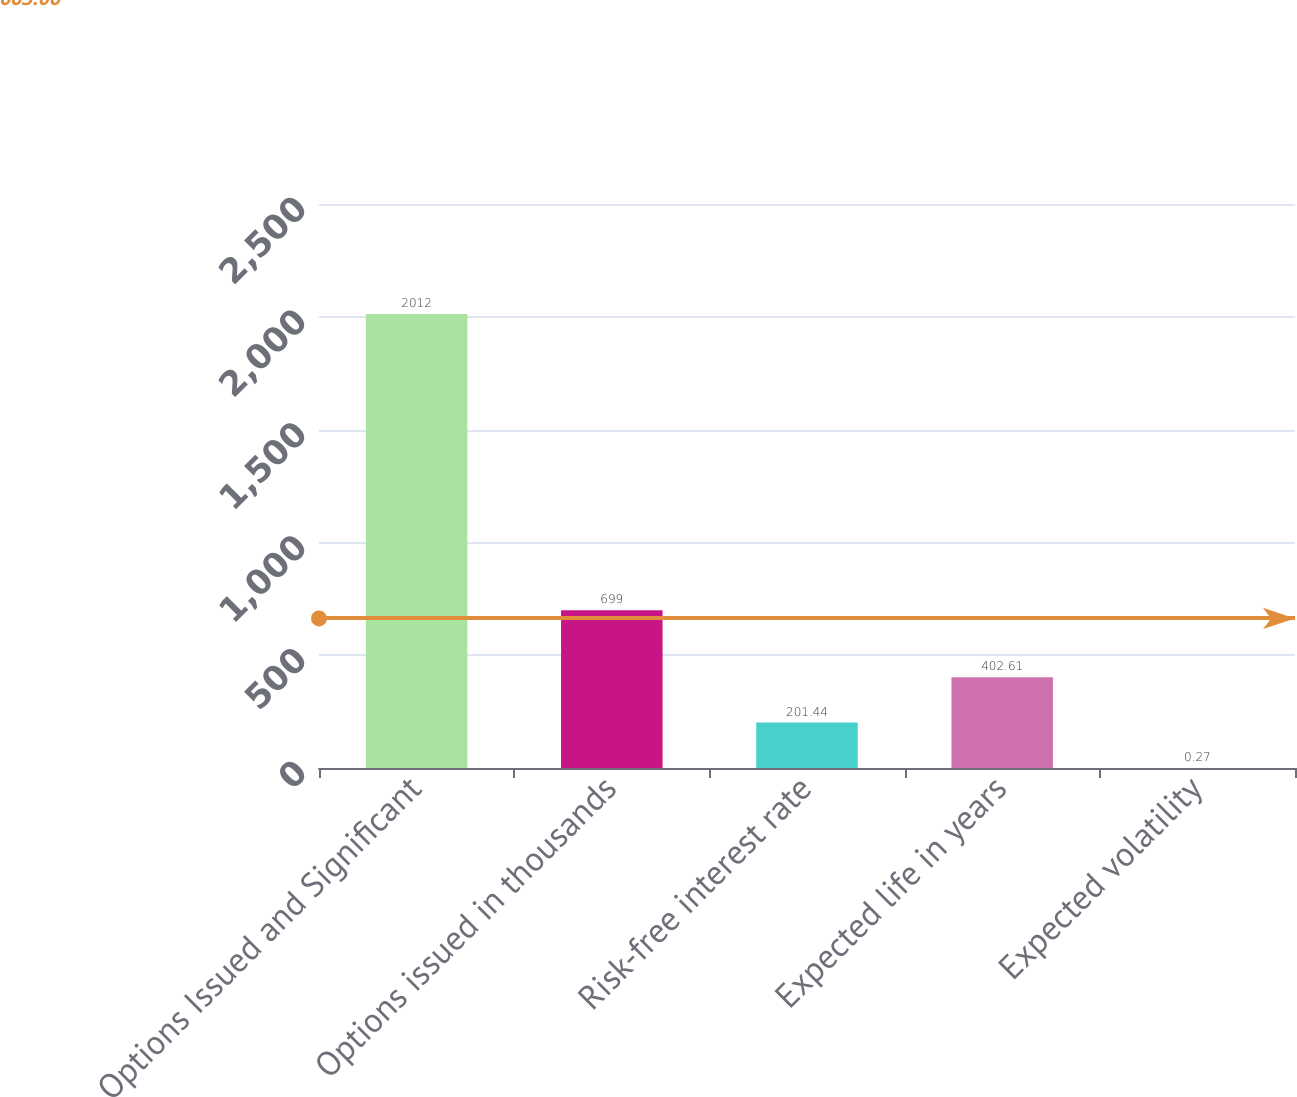<chart> <loc_0><loc_0><loc_500><loc_500><bar_chart><fcel>Options Issued and Significant<fcel>Options issued in thousands<fcel>Risk-free interest rate<fcel>Expected life in years<fcel>Expected volatility<nl><fcel>2012<fcel>699<fcel>201.44<fcel>402.61<fcel>0.27<nl></chart> 